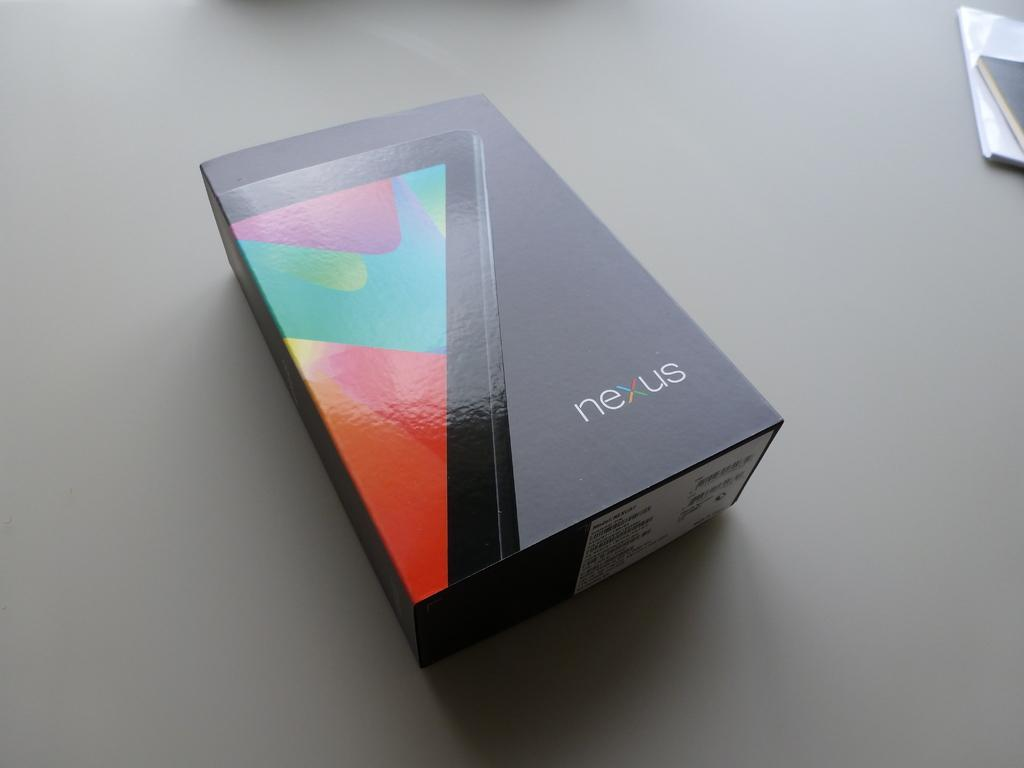<image>
Describe the image concisely. a box of a NEXUS cell phone on a grey surface 